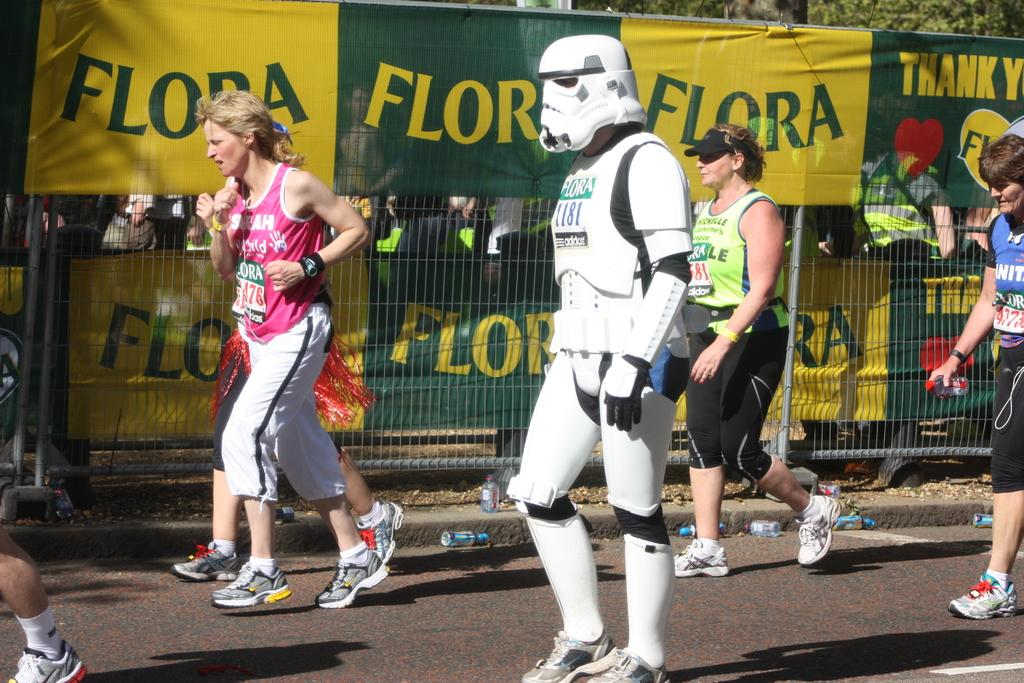<image>
Share a concise interpretation of the image provided. A man dressed as a stormtrooper walking in front of a Flora advert 